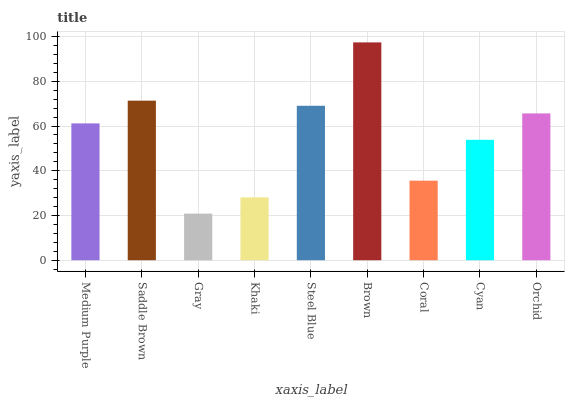Is Gray the minimum?
Answer yes or no. Yes. Is Brown the maximum?
Answer yes or no. Yes. Is Saddle Brown the minimum?
Answer yes or no. No. Is Saddle Brown the maximum?
Answer yes or no. No. Is Saddle Brown greater than Medium Purple?
Answer yes or no. Yes. Is Medium Purple less than Saddle Brown?
Answer yes or no. Yes. Is Medium Purple greater than Saddle Brown?
Answer yes or no. No. Is Saddle Brown less than Medium Purple?
Answer yes or no. No. Is Medium Purple the high median?
Answer yes or no. Yes. Is Medium Purple the low median?
Answer yes or no. Yes. Is Khaki the high median?
Answer yes or no. No. Is Saddle Brown the low median?
Answer yes or no. No. 